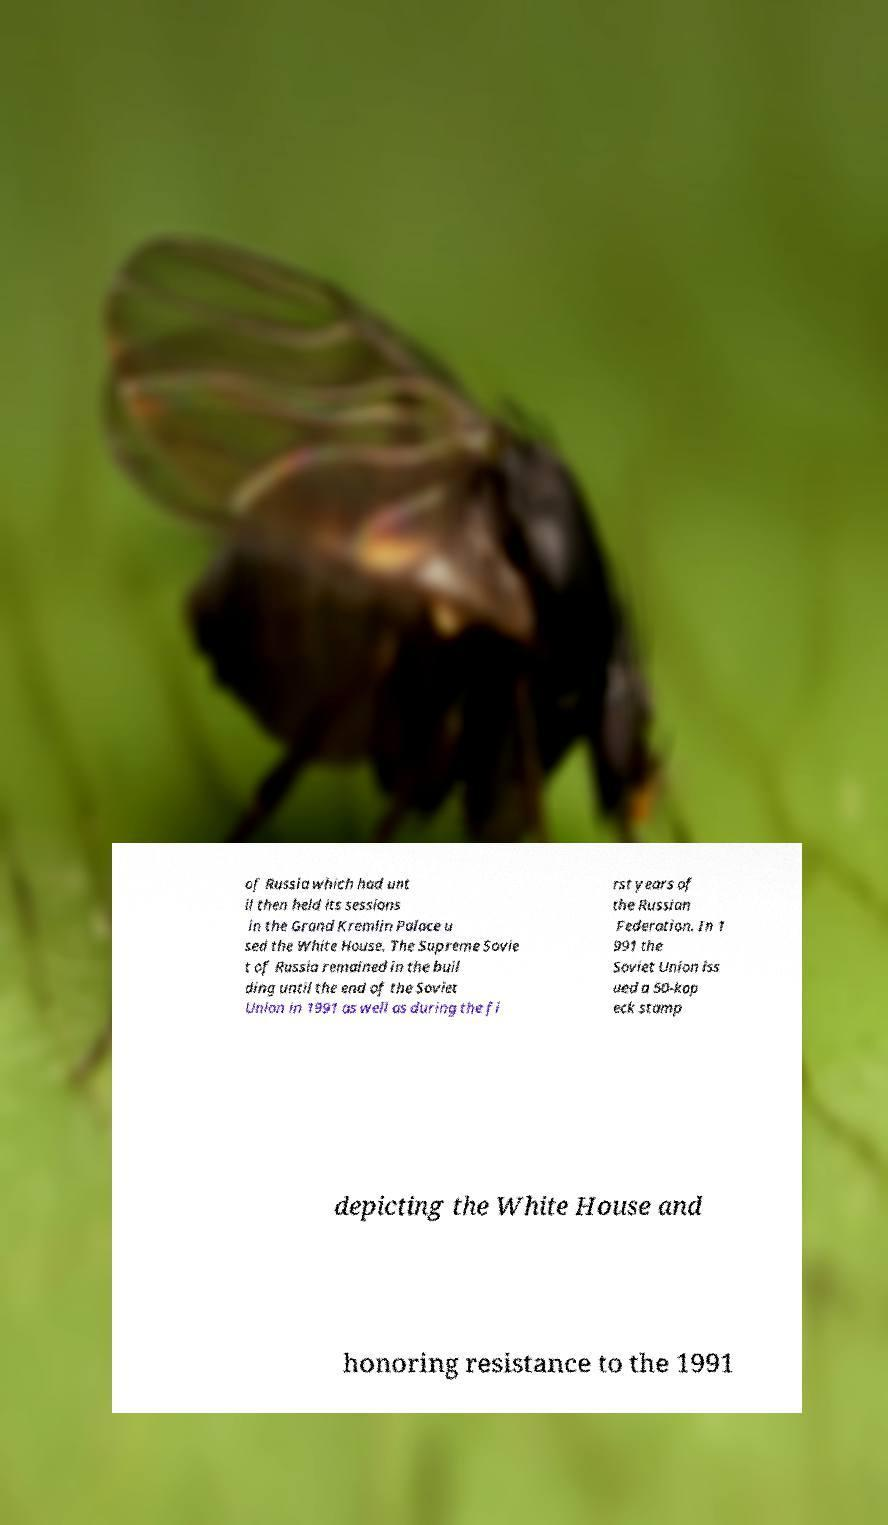For documentation purposes, I need the text within this image transcribed. Could you provide that? of Russia which had unt il then held its sessions in the Grand Kremlin Palace u sed the White House. The Supreme Sovie t of Russia remained in the buil ding until the end of the Soviet Union in 1991 as well as during the fi rst years of the Russian Federation. In 1 991 the Soviet Union iss ued a 50-kop eck stamp depicting the White House and honoring resistance to the 1991 